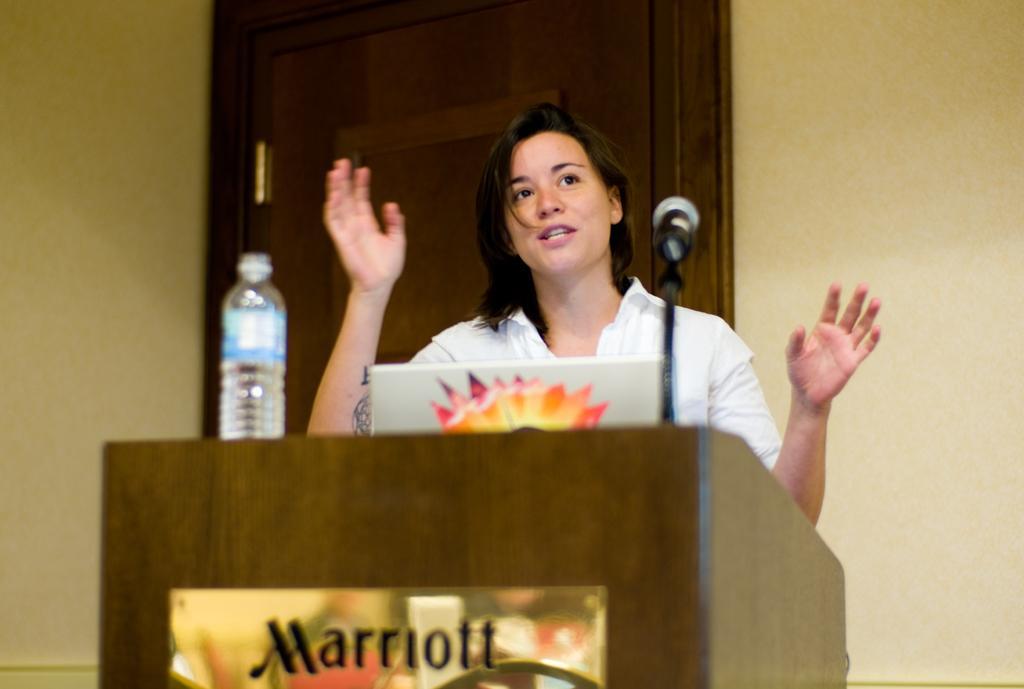Please provide a concise description of this image. In this image I can see the person standing in-front of the podium. The person is wearing the white color dress. On the podium I can see the laptop, mic and the bottle. In the background I can see the door and the wall. 